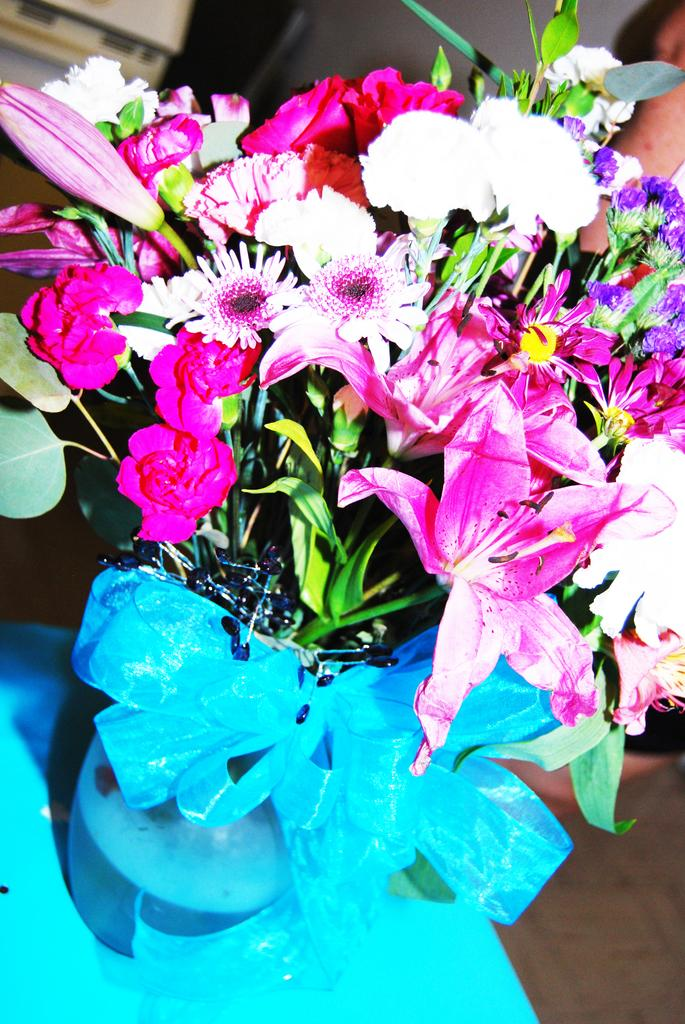What is the main subject of the image? The main subject of the image is different types of flowers. What can be seen holding the flowers in the image? The flowers are in a blue-colored pot. What are the colors of the flowers? The colors of the flowers are pink, white, and purple. What else is visible in the image besides the flowers and pot? There are green-colored leaves in the image. What type of disgust can be seen on the flowers in the image? There is no indication of disgust in the image; it features flowers in a pot with green leaves. Can you describe the clouds in the image? There are no clouds present in the image; it is focused on the flowers, pot, and leaves. 